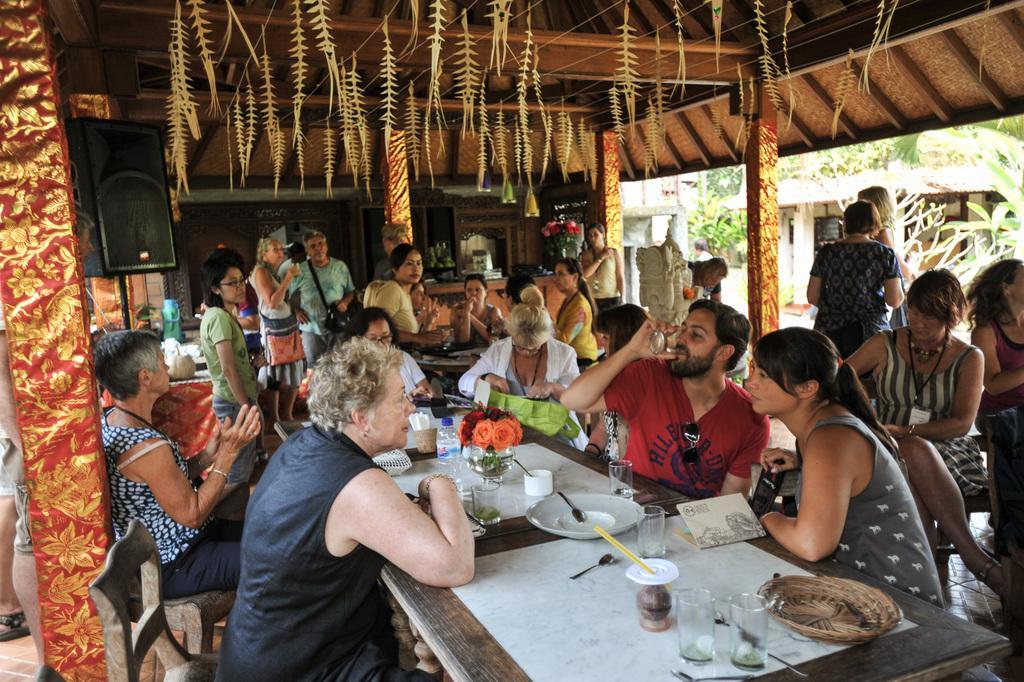Please provide a concise description of this image. In this image I can see people among them some are standing and some are sitting on chairs in front of a table. On the table I can see plates, spoons, cups, glasses and other objects. In the background I can see poles, trees and some other objects. 